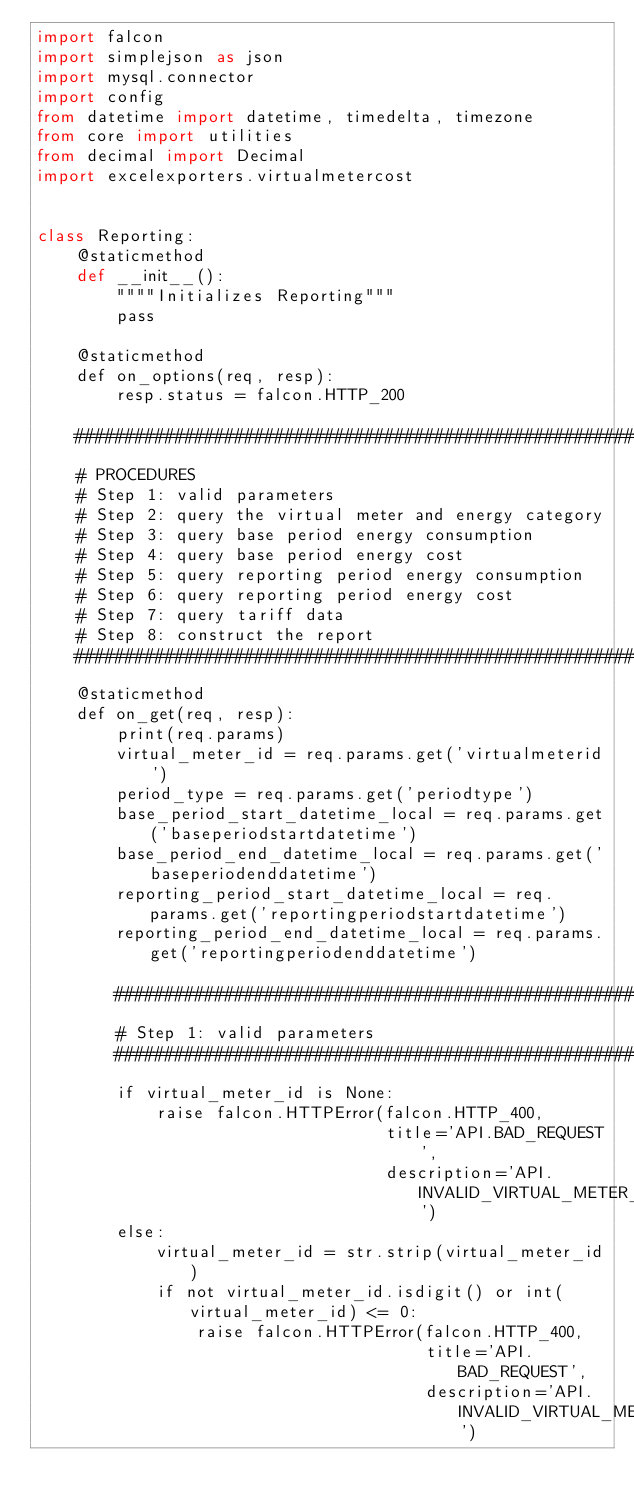<code> <loc_0><loc_0><loc_500><loc_500><_Python_>import falcon
import simplejson as json
import mysql.connector
import config
from datetime import datetime, timedelta, timezone
from core import utilities
from decimal import Decimal
import excelexporters.virtualmetercost


class Reporting:
    @staticmethod
    def __init__():
        """"Initializes Reporting"""
        pass

    @staticmethod
    def on_options(req, resp):
        resp.status = falcon.HTTP_200

    ####################################################################################################################
    # PROCEDURES
    # Step 1: valid parameters
    # Step 2: query the virtual meter and energy category
    # Step 3: query base period energy consumption
    # Step 4: query base period energy cost
    # Step 5: query reporting period energy consumption
    # Step 6: query reporting period energy cost
    # Step 7: query tariff data
    # Step 8: construct the report
    ####################################################################################################################
    @staticmethod
    def on_get(req, resp):
        print(req.params)
        virtual_meter_id = req.params.get('virtualmeterid')
        period_type = req.params.get('periodtype')
        base_period_start_datetime_local = req.params.get('baseperiodstartdatetime')
        base_period_end_datetime_local = req.params.get('baseperiodenddatetime')
        reporting_period_start_datetime_local = req.params.get('reportingperiodstartdatetime')
        reporting_period_end_datetime_local = req.params.get('reportingperiodenddatetime')

        ################################################################################################################
        # Step 1: valid parameters
        ################################################################################################################
        if virtual_meter_id is None:
            raise falcon.HTTPError(falcon.HTTP_400,
                                   title='API.BAD_REQUEST',
                                   description='API.INVALID_VIRTUAL_METER_ID')
        else:
            virtual_meter_id = str.strip(virtual_meter_id)
            if not virtual_meter_id.isdigit() or int(virtual_meter_id) <= 0:
                raise falcon.HTTPError(falcon.HTTP_400,
                                       title='API.BAD_REQUEST',
                                       description='API.INVALID_VIRTUAL_METER_ID')
</code> 